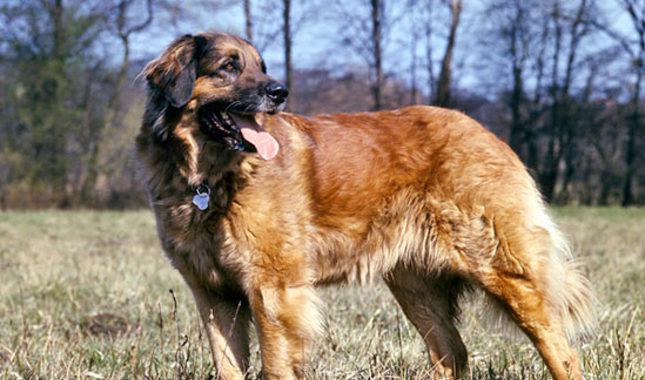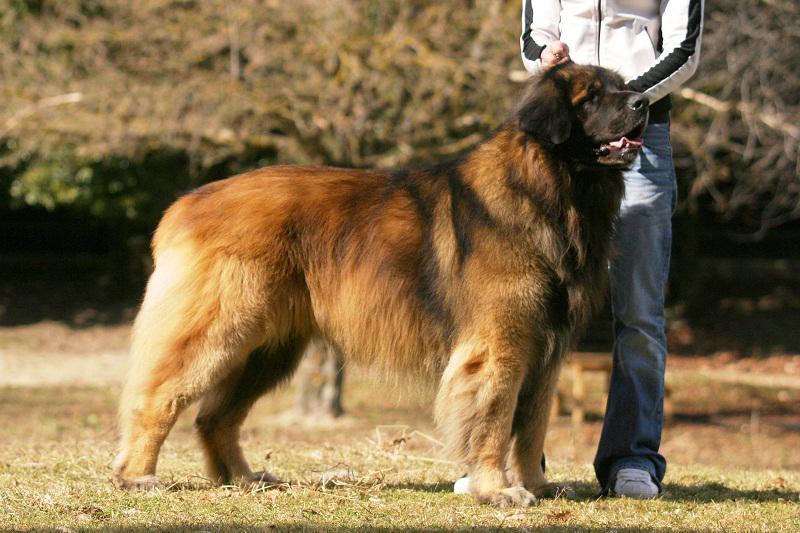The first image is the image on the left, the second image is the image on the right. Analyze the images presented: Is the assertion "The dog in the image on the right is standing in full profile facing the right." valid? Answer yes or no. Yes. 